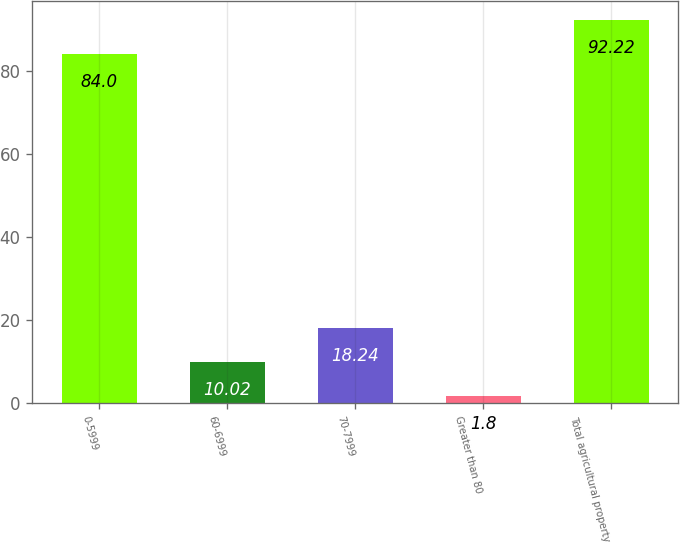Convert chart. <chart><loc_0><loc_0><loc_500><loc_500><bar_chart><fcel>0-5999<fcel>60-6999<fcel>70-7999<fcel>Greater than 80<fcel>Total agricultural property<nl><fcel>84<fcel>10.02<fcel>18.24<fcel>1.8<fcel>92.22<nl></chart> 